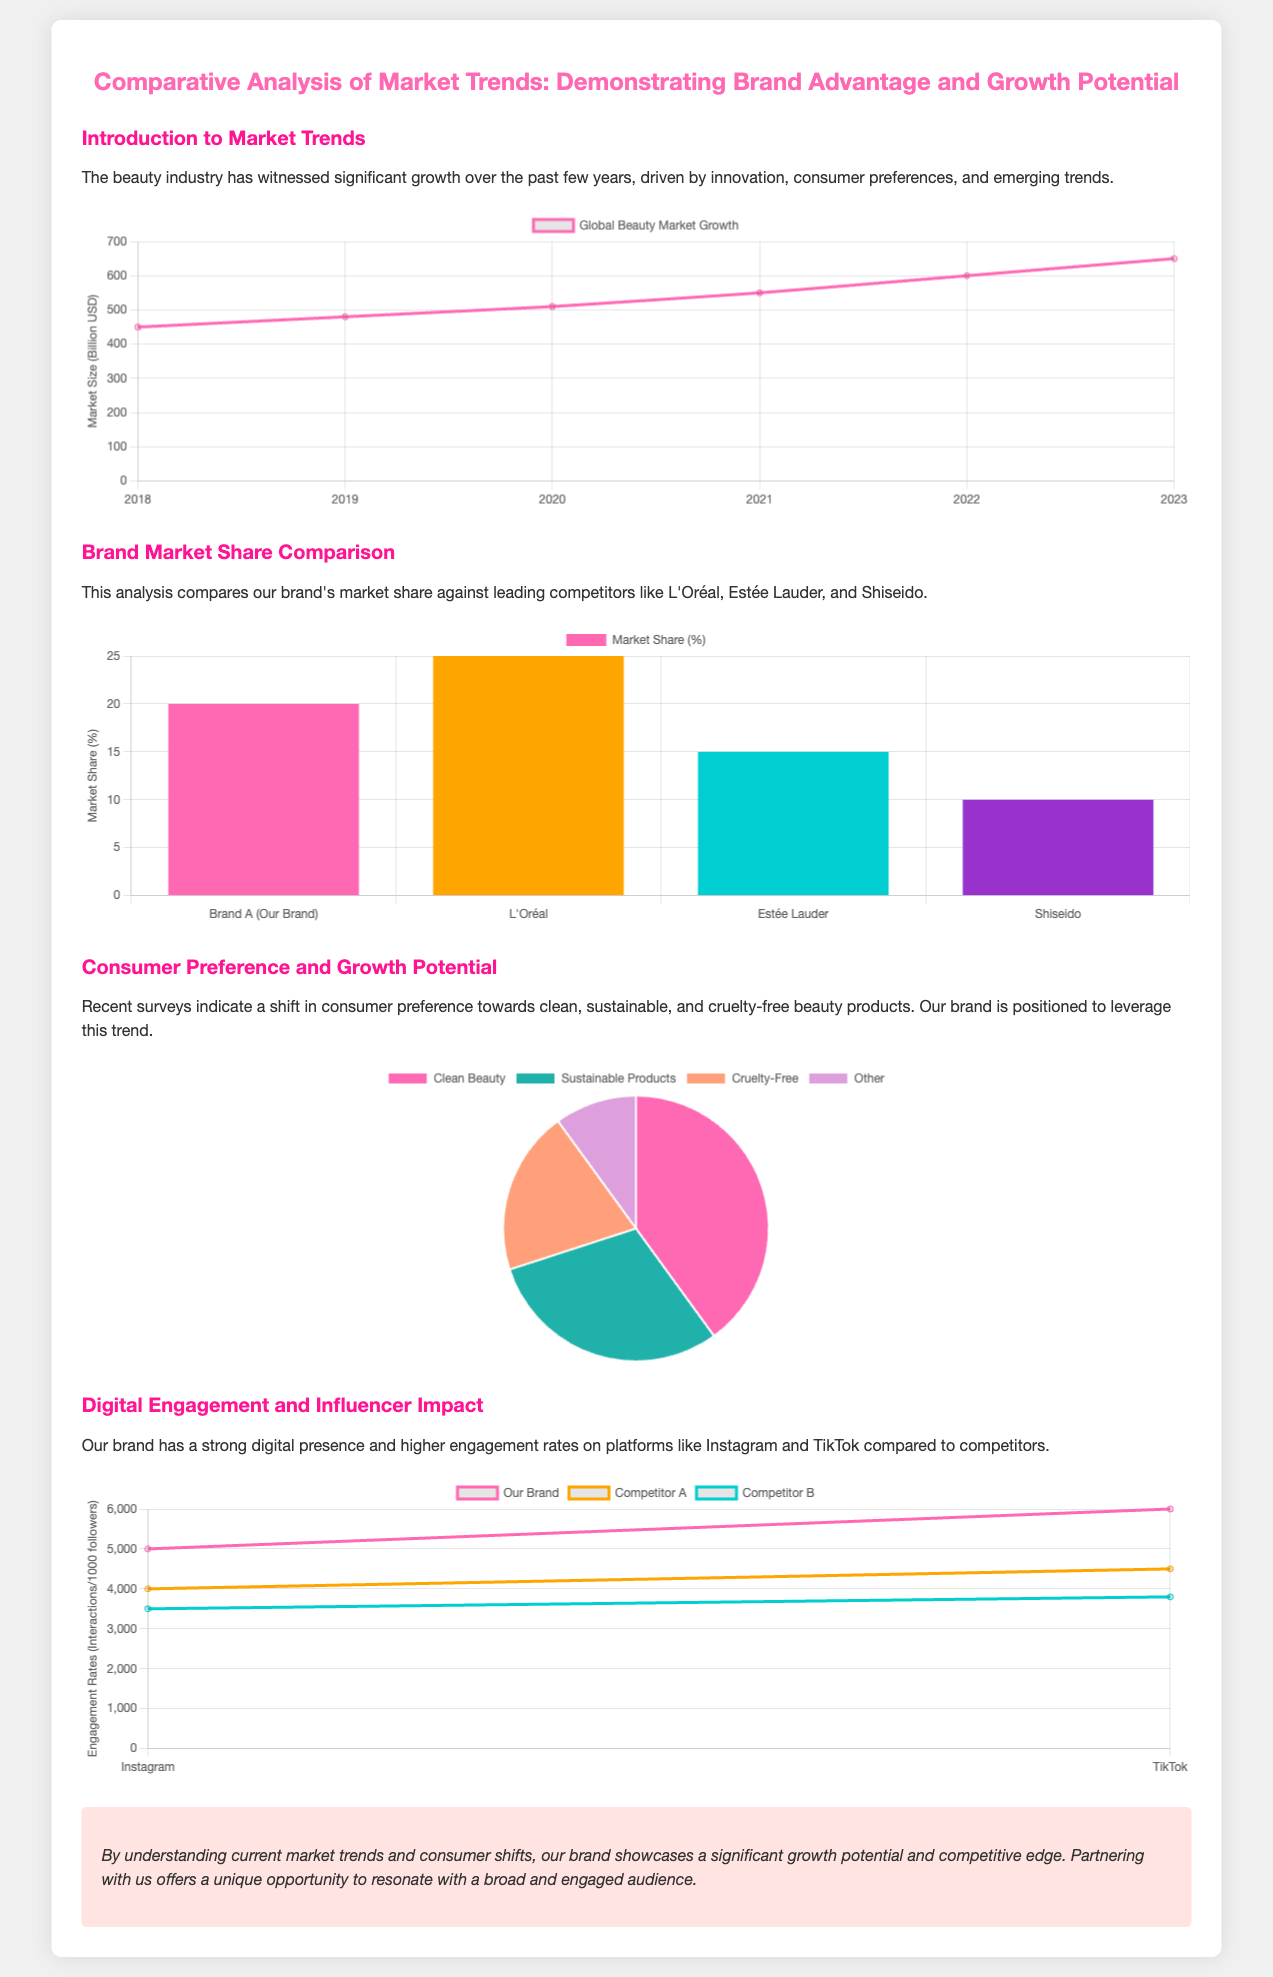What was the market size in 2023? The market size in 2023 according to the market trends chart is represented as 650 billion USD.
Answer: 650 billion USD What percentage of the market share does L'Oréal hold? The market share chart indicates that L'Oréal holds 25% of the market share.
Answer: 25% Which consumer preference category has the highest percentage? The consumer preference chart shows that 'Clean Beauty' has the highest percentage at 40%.
Answer: Clean Beauty How is our brand positioned in the digital engagement comparison? The digital engagement chart shows that our brand has higher engagement rates than both Competitor A and Competitor B.
Answer: Higher engagement rates What trend is driving the growth in the beauty industry? The introduction states that innovation, consumer preferences, and emerging trends are driving the industry's growth.
Answer: Innovation and consumer preferences What is the percentage of consumers preferring cruelty-free products? The consumer preference chart shows that 20% of consumers prefer cruelty-free products.
Answer: 20% Who are the leading competitors mentioned in the market share comparison? The market share comparison section mentions L'Oréal, Estée Lauder, and Shiseido as leading competitors.
Answer: L'Oréal, Estée Lauder, Shiseido What is the overall conclusion indicated in the presentation? The conclusion asserts that the brand showcases significant growth potential and competitive edge.
Answer: Significant growth potential and competitive edge 